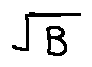Convert formula to latex. <formula><loc_0><loc_0><loc_500><loc_500>\sqrt { B }</formula> 